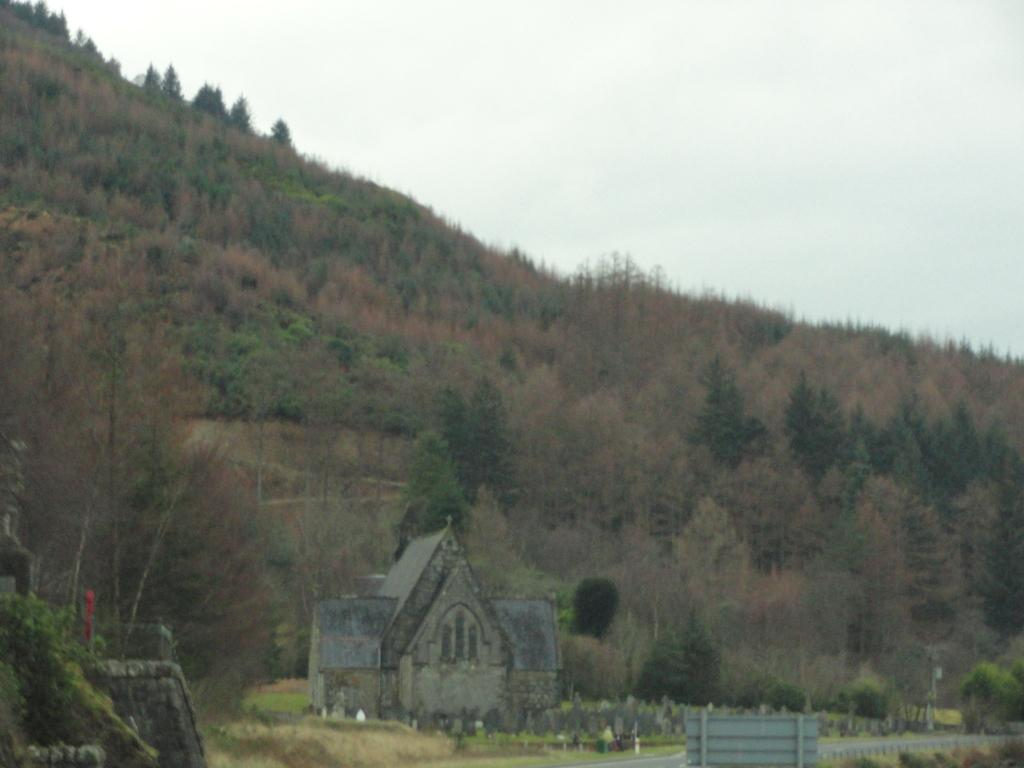What type of structure is present in the image? There is a building in the image. What can be seen in the background of the image? There are trees in the background of the image. What is the color of the trees? The trees are green. What is visible above the trees in the image? The sky is visible in the image. What is the color of the sky? The sky is white in color. How many tomatoes are hanging from the branches of the trees in the image? There are no tomatoes present in the image; the trees are green, but no specific fruits or vegetables are mentioned. 